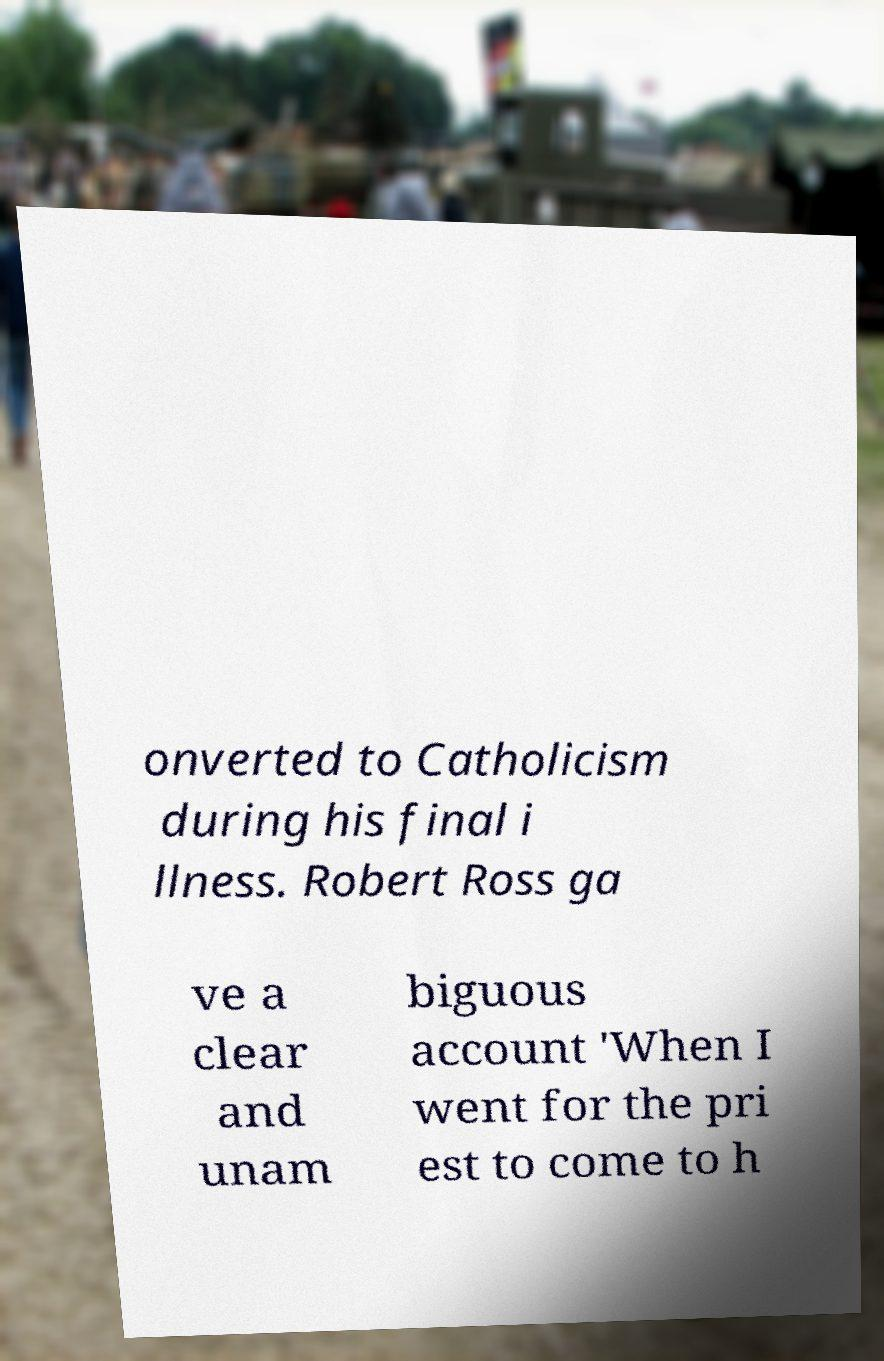Can you read and provide the text displayed in the image?This photo seems to have some interesting text. Can you extract and type it out for me? onverted to Catholicism during his final i llness. Robert Ross ga ve a clear and unam biguous account 'When I went for the pri est to come to h 